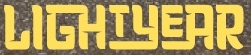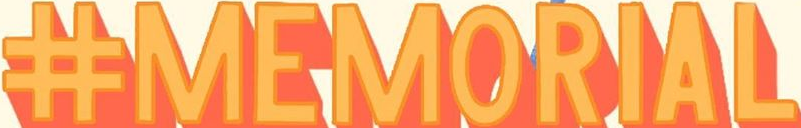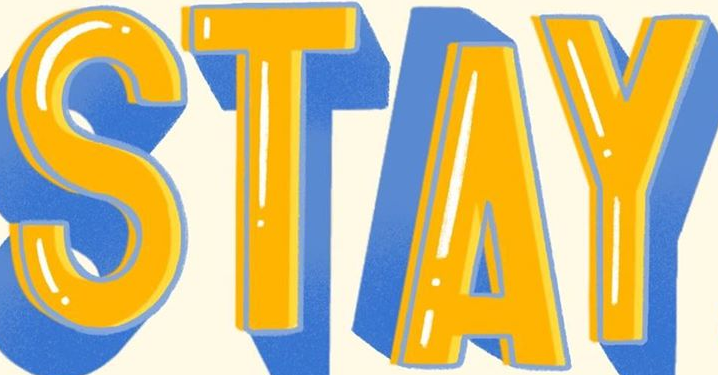Read the text from these images in sequence, separated by a semicolon. LIGHTYEAR; #MEMORIAL; STAY 